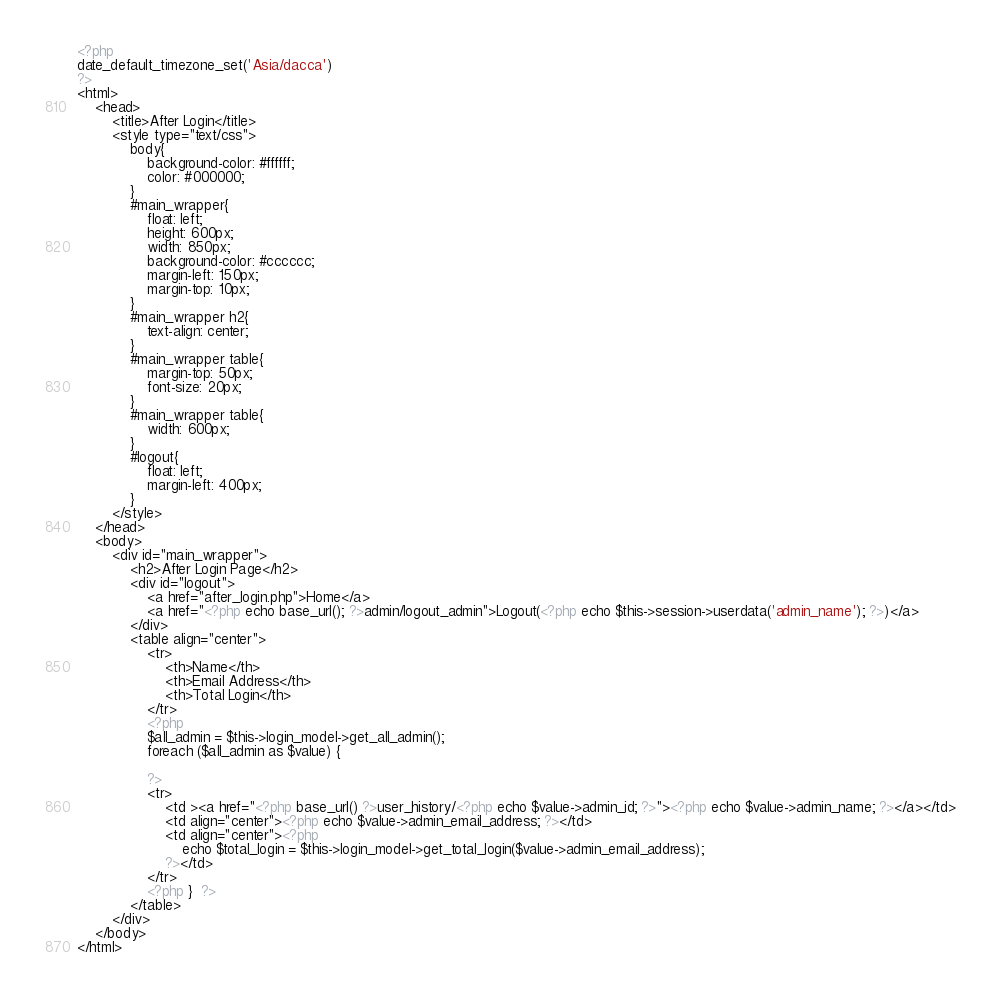Convert code to text. <code><loc_0><loc_0><loc_500><loc_500><_PHP_><?php
date_default_timezone_set('Asia/dacca')
?>
<html>
    <head>
        <title>After Login</title>
        <style type="text/css">
            body{
                background-color: #ffffff;
                color: #000000;
            }
            #main_wrapper{
                float: left;
                height: 600px;
                width: 850px;
                background-color: #cccccc;
                margin-left: 150px;
                margin-top: 10px;
            }
            #main_wrapper h2{
                text-align: center;
            }
            #main_wrapper table{
                margin-top: 50px;
                font-size: 20px;
            }
            #main_wrapper table{
                width: 600px;
            }
            #logout{
                float: left;
                margin-left: 400px;
            }
        </style>
    </head>
    <body>
        <div id="main_wrapper">
            <h2>After Login Page</h2>
            <div id="logout">
                <a href="after_login.php">Home</a>
                <a href="<?php echo base_url(); ?>admin/logout_admin">Logout(<?php echo $this->session->userdata('admin_name'); ?>)</a>
            </div>
            <table align="center">
                <tr>
                    <th>Name</th>
                    <th>Email Address</th>
                    <th>Total Login</th>
                </tr>
                <?php
                $all_admin = $this->login_model->get_all_admin();
                foreach ($all_admin as $value) {
                    
                ?>
                <tr>
                    <td ><a href="<?php base_url() ?>user_history/<?php echo $value->admin_id; ?>"><?php echo $value->admin_name; ?></a></td>
                    <td align="center"><?php echo $value->admin_email_address; ?></td>
                    <td align="center"><?php 
                        echo $total_login = $this->login_model->get_total_login($value->admin_email_address);
                    ?></td>
                </tr>
                <?php }  ?>
            </table>
        </div>
    </body>
</html>
</code> 